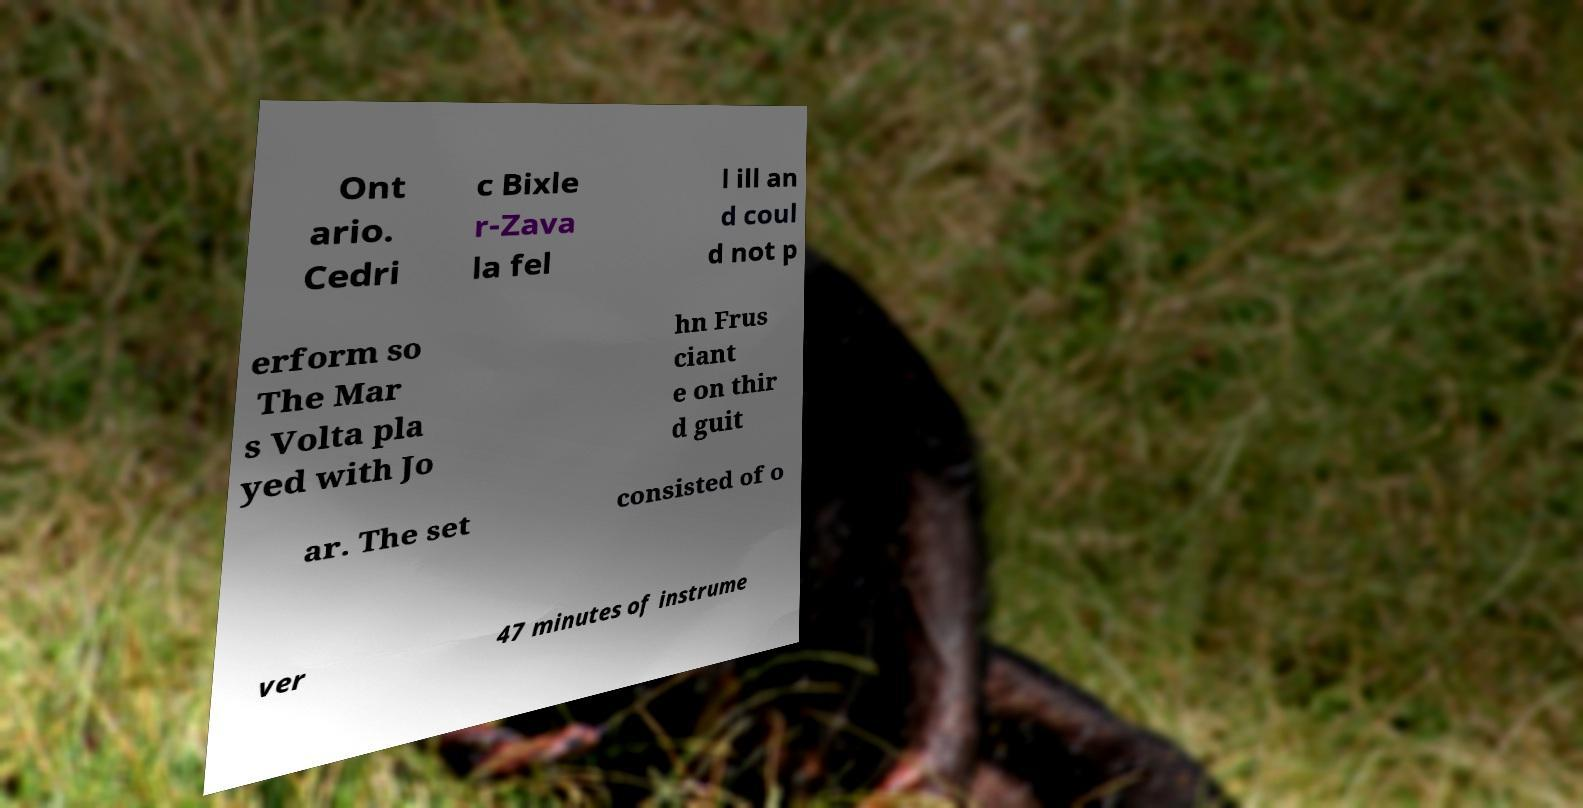Please read and relay the text visible in this image. What does it say? Ont ario. Cedri c Bixle r-Zava la fel l ill an d coul d not p erform so The Mar s Volta pla yed with Jo hn Frus ciant e on thir d guit ar. The set consisted of o ver 47 minutes of instrume 